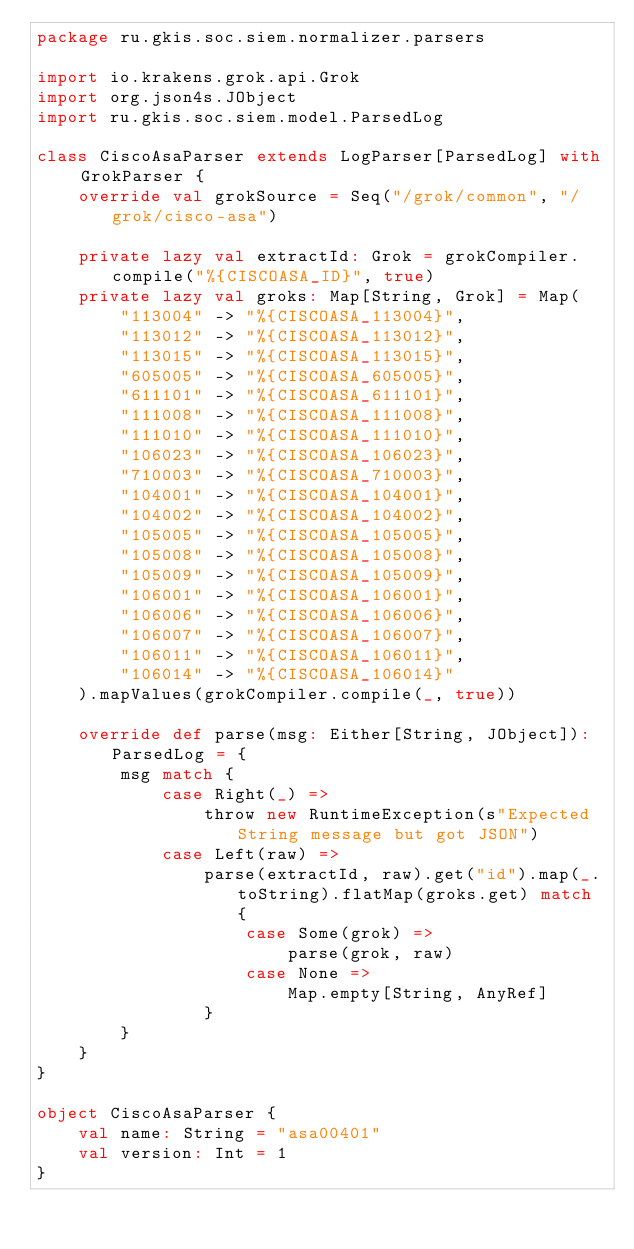<code> <loc_0><loc_0><loc_500><loc_500><_Scala_>package ru.gkis.soc.siem.normalizer.parsers

import io.krakens.grok.api.Grok
import org.json4s.JObject
import ru.gkis.soc.siem.model.ParsedLog

class CiscoAsaParser extends LogParser[ParsedLog] with GrokParser {
    override val grokSource = Seq("/grok/common", "/grok/cisco-asa")

    private lazy val extractId: Grok = grokCompiler.compile("%{CISCOASA_ID}", true)
    private lazy val groks: Map[String, Grok] = Map(
        "113004" -> "%{CISCOASA_113004}",
        "113012" -> "%{CISCOASA_113012}",
        "113015" -> "%{CISCOASA_113015}",
        "605005" -> "%{CISCOASA_605005}",
        "611101" -> "%{CISCOASA_611101}",
        "111008" -> "%{CISCOASA_111008}",
        "111010" -> "%{CISCOASA_111010}",
        "106023" -> "%{CISCOASA_106023}",
        "710003" -> "%{CISCOASA_710003}",
        "104001" -> "%{CISCOASA_104001}",
        "104002" -> "%{CISCOASA_104002}",
        "105005" -> "%{CISCOASA_105005}",
        "105008" -> "%{CISCOASA_105008}",
        "105009" -> "%{CISCOASA_105009}",
        "106001" -> "%{CISCOASA_106001}",
        "106006" -> "%{CISCOASA_106006}",
        "106007" -> "%{CISCOASA_106007}",
        "106011" -> "%{CISCOASA_106011}",
        "106014" -> "%{CISCOASA_106014}"
    ).mapValues(grokCompiler.compile(_, true))

    override def parse(msg: Either[String, JObject]): ParsedLog = {
        msg match {
            case Right(_) =>
                throw new RuntimeException(s"Expected String message but got JSON")
            case Left(raw) =>
                parse(extractId, raw).get("id").map(_.toString).flatMap(groks.get) match {
                    case Some(grok) =>
                        parse(grok, raw)
                    case None =>
                        Map.empty[String, AnyRef]
                }
        }
    }
}

object CiscoAsaParser {
    val name: String = "asa00401"
    val version: Int = 1
}</code> 